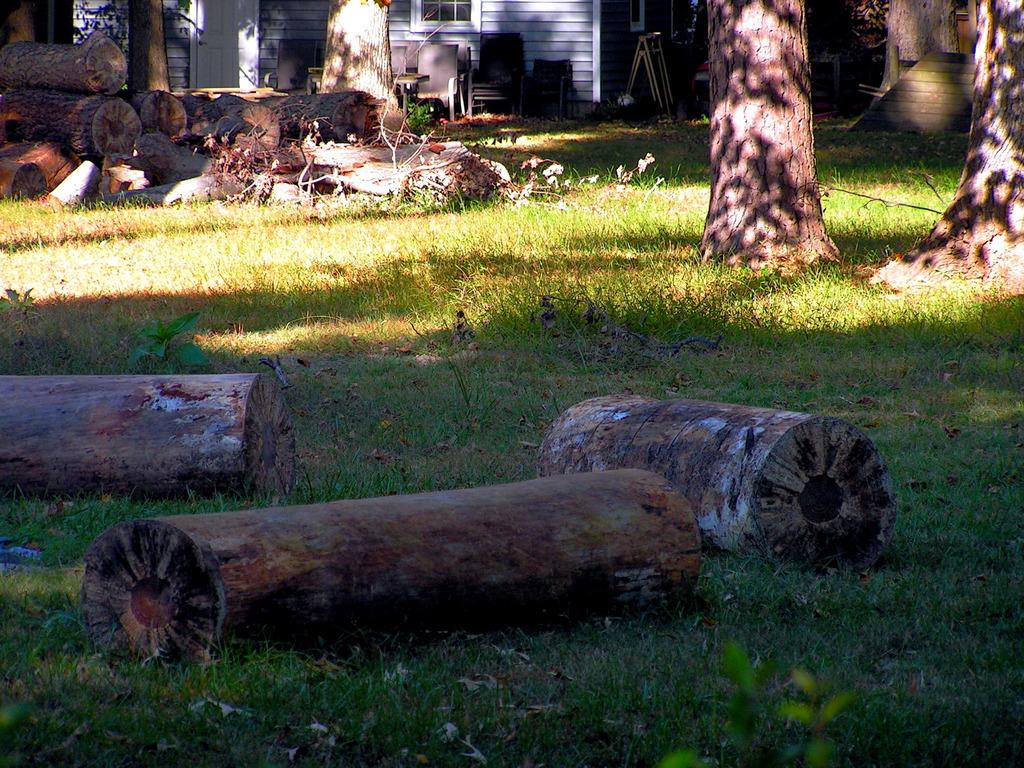What objects are present on the grass in the image? There are trunks on the grass in the image. What type of furniture can be seen in the image? There are chairs in the image. What architectural features are visible in the image? There is a wall, a window, and a door visible in the image. Where is the staircase located in the image? The staircase is on the right side of the image. Can you see a monkey climbing the wall in the image? No, there is no monkey present in the image. Are there any slaves depicted in the image? No, there are no slaves depicted in the image. 